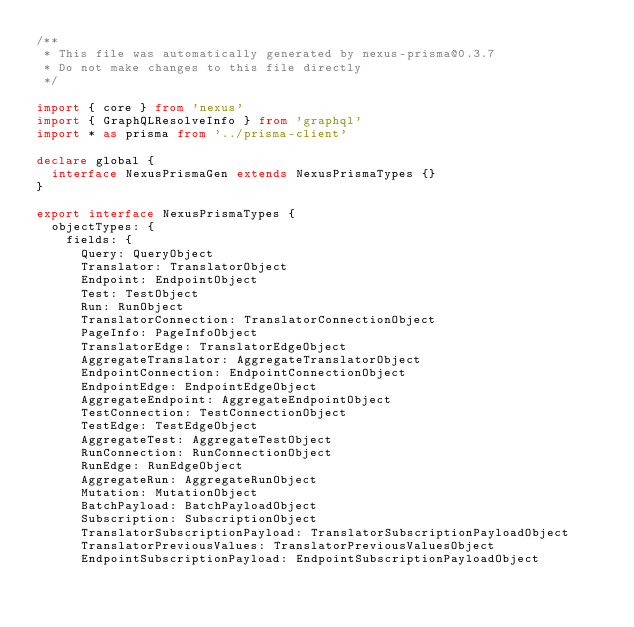Convert code to text. <code><loc_0><loc_0><loc_500><loc_500><_TypeScript_>/**
 * This file was automatically generated by nexus-prisma@0.3.7
 * Do not make changes to this file directly
 */

import { core } from 'nexus'
import { GraphQLResolveInfo } from 'graphql'
import * as prisma from '../prisma-client'

declare global {
  interface NexusPrismaGen extends NexusPrismaTypes {}
}

export interface NexusPrismaTypes {
  objectTypes: {
    fields: {
      Query: QueryObject
      Translator: TranslatorObject
      Endpoint: EndpointObject
      Test: TestObject
      Run: RunObject
      TranslatorConnection: TranslatorConnectionObject
      PageInfo: PageInfoObject
      TranslatorEdge: TranslatorEdgeObject
      AggregateTranslator: AggregateTranslatorObject
      EndpointConnection: EndpointConnectionObject
      EndpointEdge: EndpointEdgeObject
      AggregateEndpoint: AggregateEndpointObject
      TestConnection: TestConnectionObject
      TestEdge: TestEdgeObject
      AggregateTest: AggregateTestObject
      RunConnection: RunConnectionObject
      RunEdge: RunEdgeObject
      AggregateRun: AggregateRunObject
      Mutation: MutationObject
      BatchPayload: BatchPayloadObject
      Subscription: SubscriptionObject
      TranslatorSubscriptionPayload: TranslatorSubscriptionPayloadObject
      TranslatorPreviousValues: TranslatorPreviousValuesObject
      EndpointSubscriptionPayload: EndpointSubscriptionPayloadObject</code> 